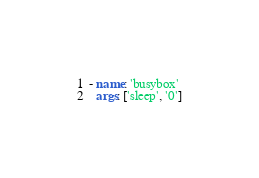<code> <loc_0><loc_0><loc_500><loc_500><_YAML_>- name: 'busybox'
  args: ['sleep', '0']
</code> 